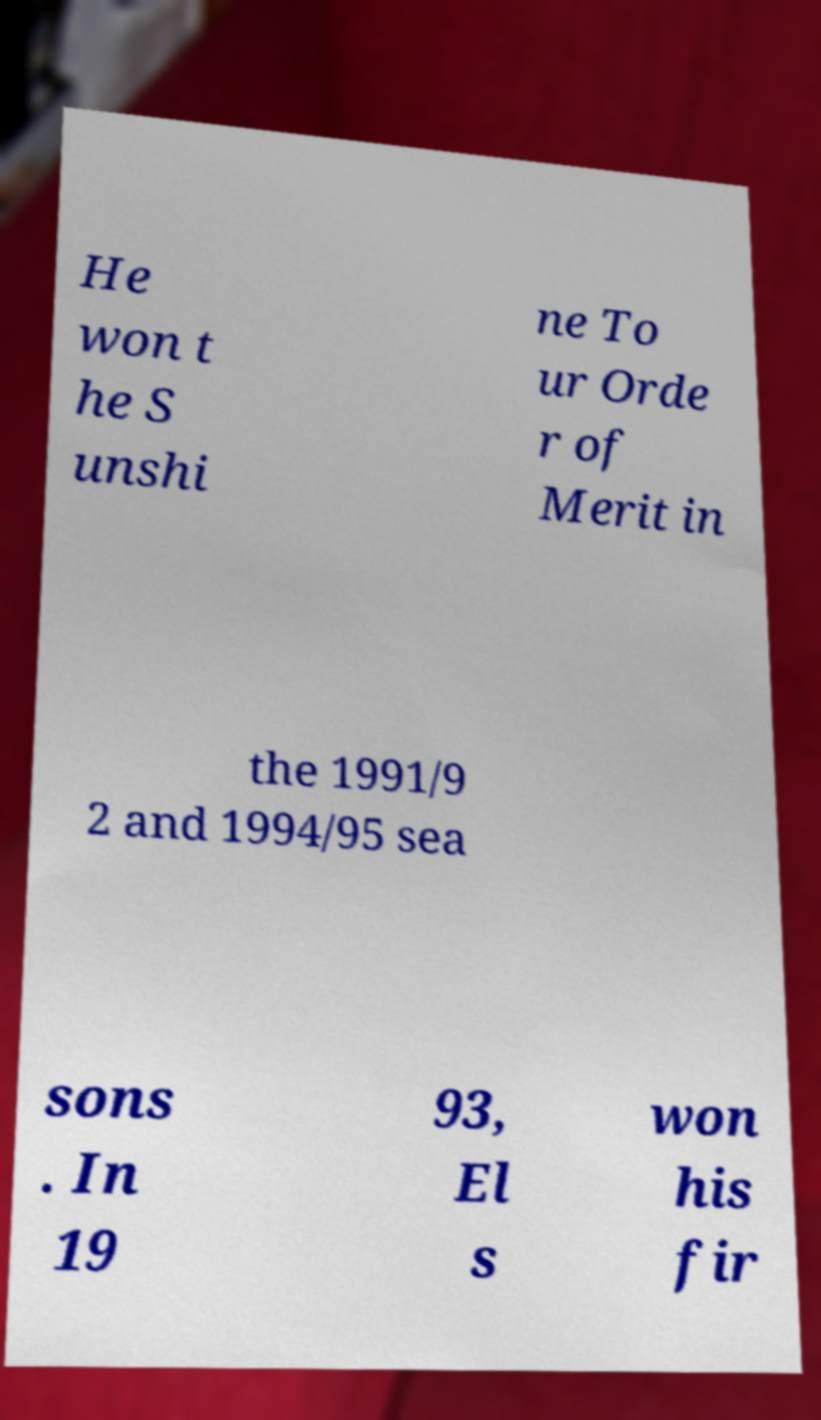Could you extract and type out the text from this image? He won t he S unshi ne To ur Orde r of Merit in the 1991/9 2 and 1994/95 sea sons . In 19 93, El s won his fir 